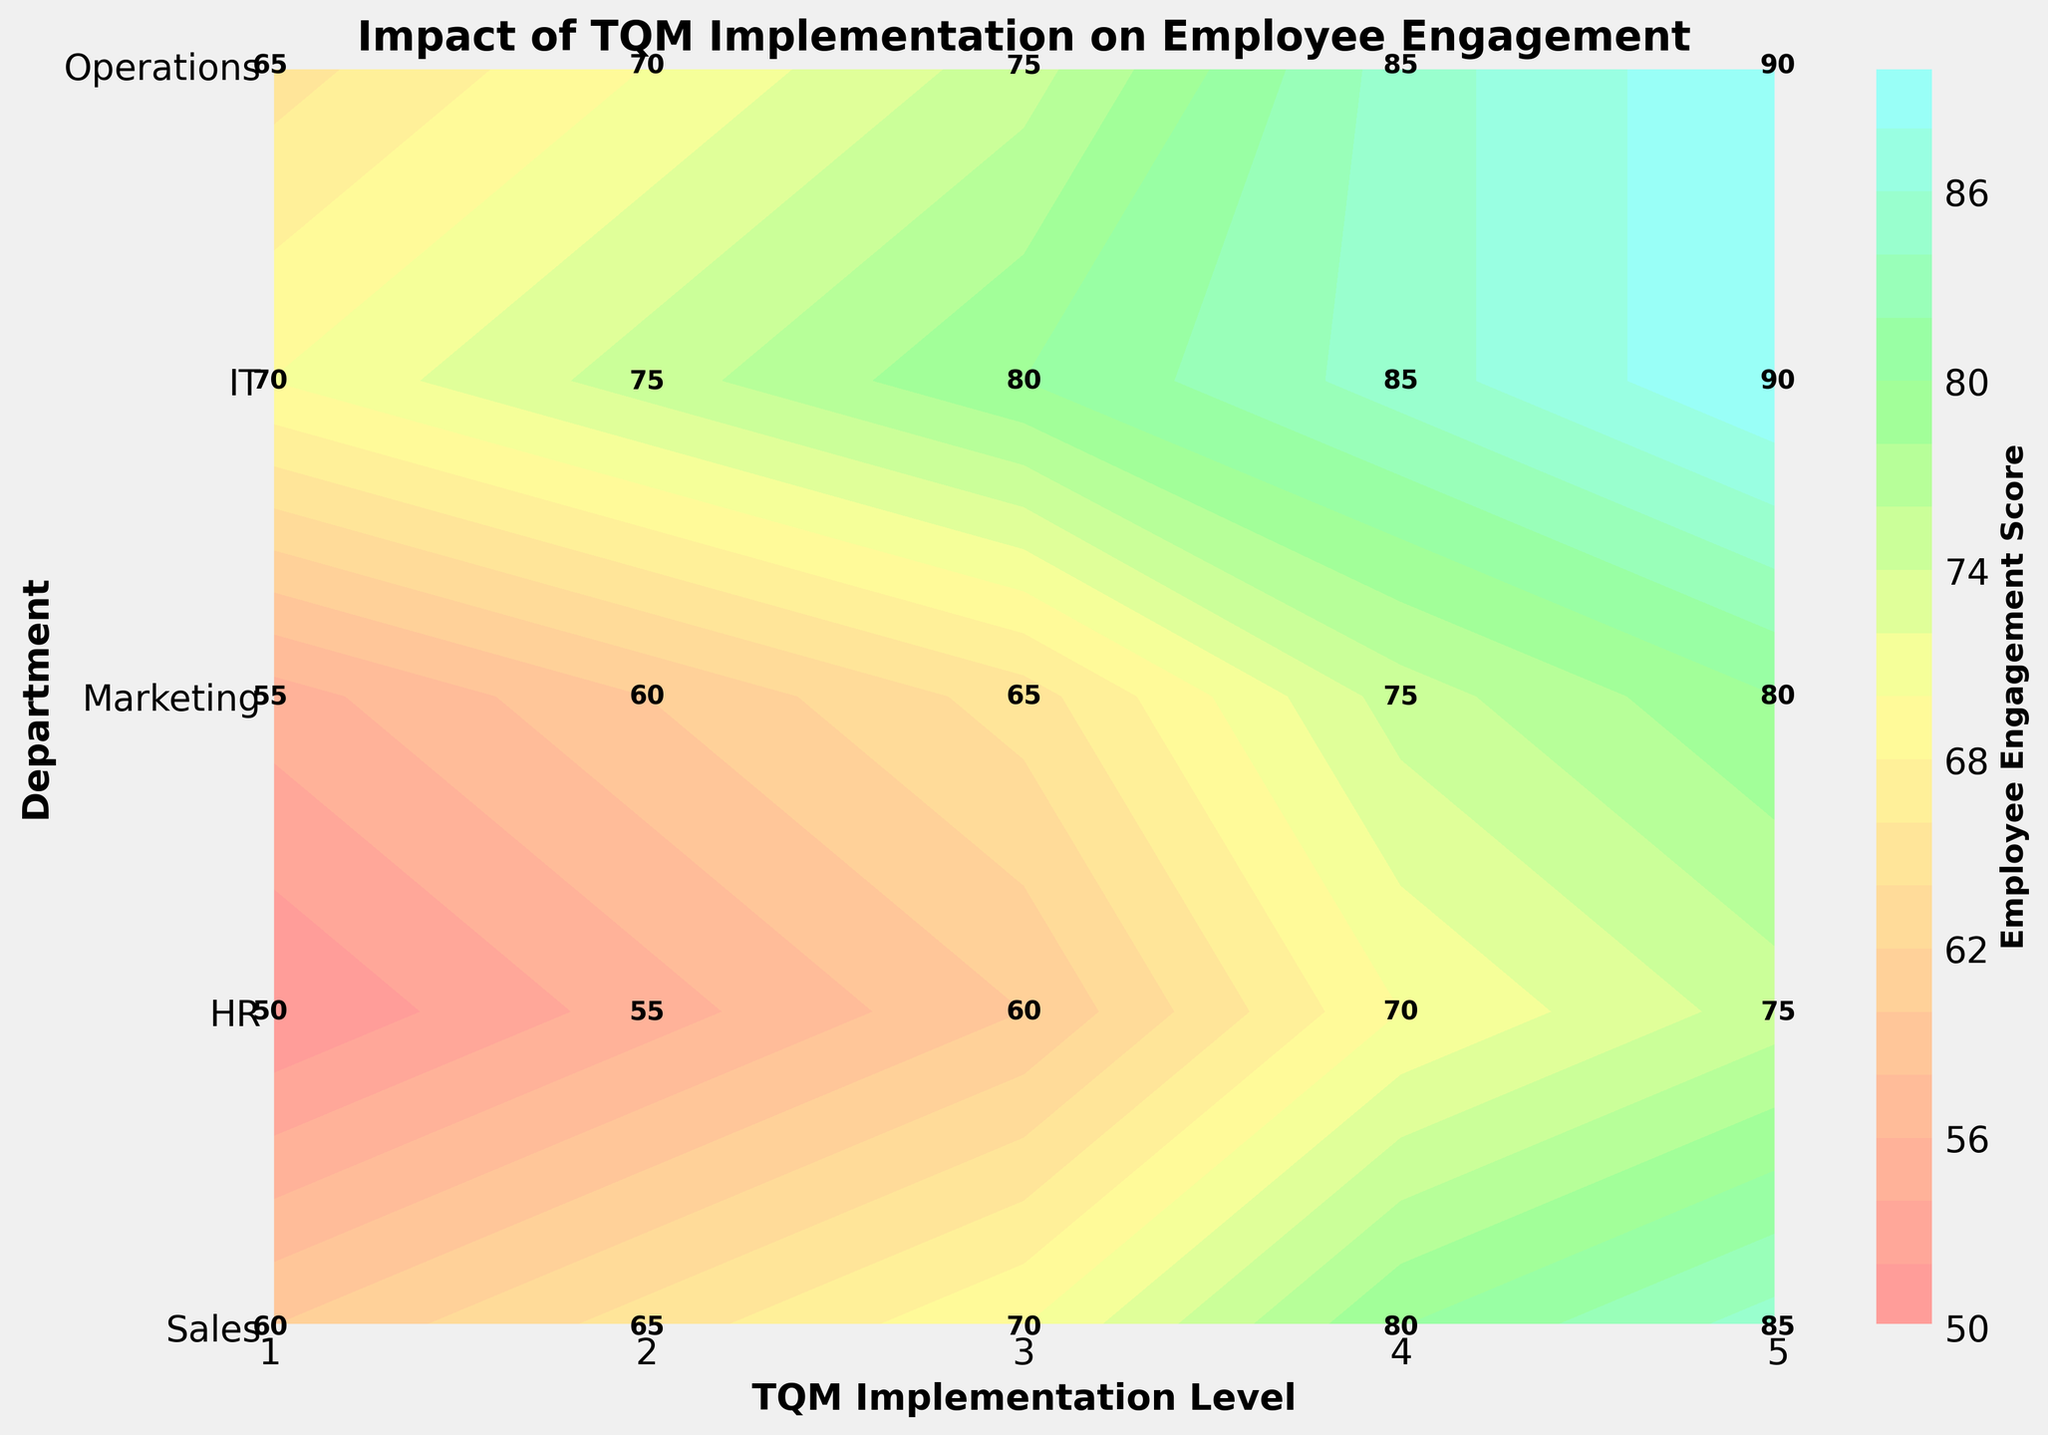What is the title of the plot? The title of the plot is located at the top center of the figure. It gives an overview of what the figure is depicting.
Answer: Impact of TQM Implementation on Employee Engagement Which department has the highest Employee Engagement score at TQM Level 5? Looking across the different departments at the TQM Level 5, identify the one with the highest numerical value for Employee Engagement score.
Answer: Sales and Operations How does the Employee Engagement score in the IT department change from TQM Level 1 to TQM Level 5? Track the progression of the engagement score in the IT department from level 1 through level 5 along the x-axis and document the values.
Answer: It increases from 50 to 75 Which department shows the largest increase in Employee Engagement when moving from TQM Level 2 to TQM Level 4? Calculate the differences in Employee Engagement scores between levels 2 and 4 for each department and identify the maximum.
Answer: Sales What is the average Employee Engagement score for the Marketing department across all TQM levels? Sum all the Employee Engagement scores for Marketing and divide by the number of TQM levels. (55 + 60 + 65 + 75 + 80) / 5 = 67
Answer: 67 Which two departments have equal Employee Engagement scores at any TQM level? Compare the engagement scores across all TQM levels to find two departments with matching values. Focus specifically on levels where scores match.
Answer: Sales and Operations at TQM Level 4 and TQM Level 5 What is the color indicating the highest Employee Engagement score on the plot? Look at the colorbar to determine which color corresponds to the highest values of Employee Engagement score.
Answer: Cyan (#99FFFF) How does the Employee Engagement score trend for the HR department as the TQM level increases? Observe the progression of scores for the HR department from TQM level 1 to TQM level 5 and describe the trend.
Answer: It consistently increases from 60 to 85 Which department has the lowest Employee Engagement score at TQM Level 1? Compare the Employee Engagement scores at TQM Level 1 across all departments and identify the lowest one.
Answer: IT What is the range of Employee Engagement scores in the Operations department across all TQM Levels? Identify the minimum and maximum scores for the Operations department and subtract the minimum from the maximum. The range is 90 - 70 = 20.
Answer: 20 